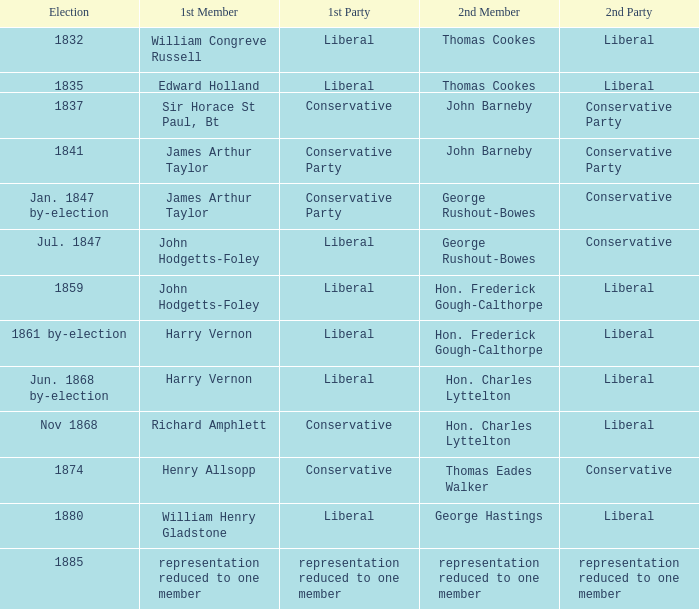When william congreve russell was the first member, which party did he belong to? Liberal. 